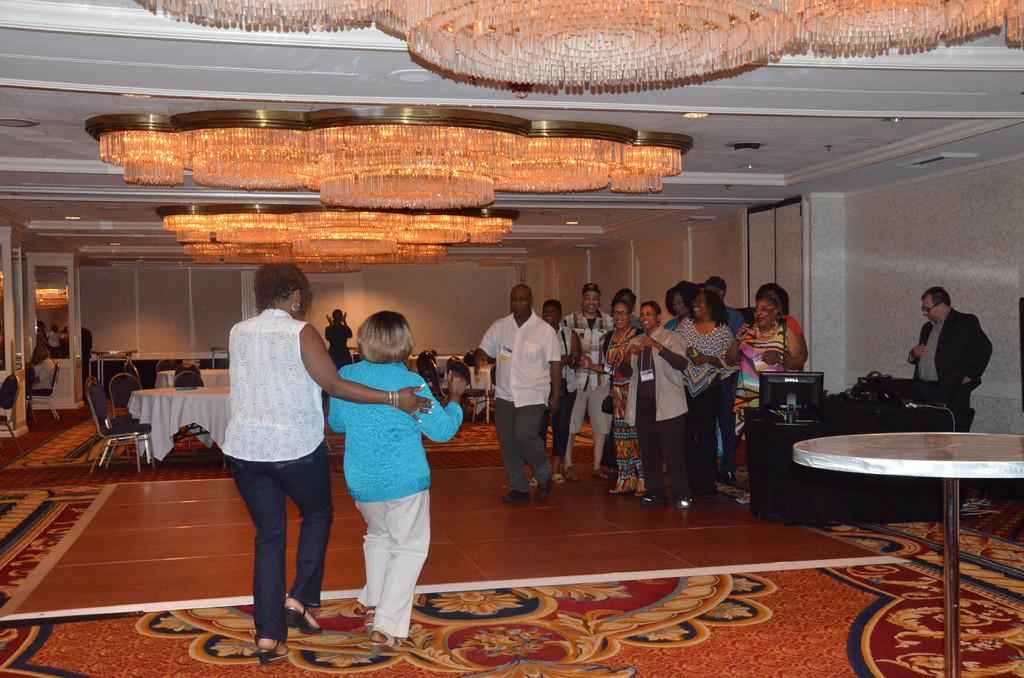What type of flooring is present in the image? The floor has a carpet. What furniture can be seen in the image? There are tables and chairs in the image. What is placed on top of the tables? There are lights on top of the tables. Are there any people in the image? Yes, there are people standing in the image. What electronic device is present on one of the tables? There is a monitor on one of the tables. Can you see any smoke in the image? There is no smoke visible in the image. Is there a rifle present in the image? There is no rifle present in the image. 